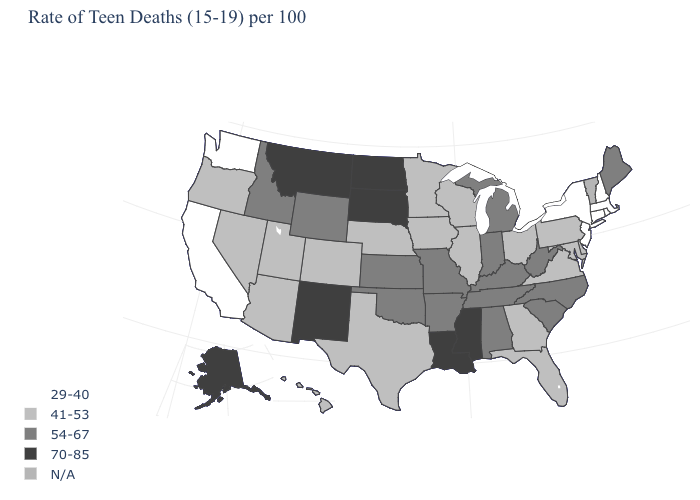Name the states that have a value in the range 41-53?
Write a very short answer. Arizona, Colorado, Delaware, Florida, Georgia, Hawaii, Illinois, Iowa, Maryland, Minnesota, Nebraska, Nevada, Ohio, Oregon, Pennsylvania, Texas, Utah, Virginia, Wisconsin. What is the value of Nevada?
Concise answer only. 41-53. What is the highest value in the USA?
Concise answer only. 70-85. Name the states that have a value in the range 29-40?
Keep it brief. California, Connecticut, Massachusetts, New Hampshire, New Jersey, New York, Rhode Island, Washington. Name the states that have a value in the range 54-67?
Write a very short answer. Alabama, Arkansas, Idaho, Indiana, Kansas, Kentucky, Maine, Michigan, Missouri, North Carolina, Oklahoma, South Carolina, Tennessee, West Virginia, Wyoming. Name the states that have a value in the range 54-67?
Give a very brief answer. Alabama, Arkansas, Idaho, Indiana, Kansas, Kentucky, Maine, Michigan, Missouri, North Carolina, Oklahoma, South Carolina, Tennessee, West Virginia, Wyoming. Name the states that have a value in the range 70-85?
Quick response, please. Alaska, Louisiana, Mississippi, Montana, New Mexico, North Dakota, South Dakota. Name the states that have a value in the range 70-85?
Be succinct. Alaska, Louisiana, Mississippi, Montana, New Mexico, North Dakota, South Dakota. Name the states that have a value in the range 54-67?
Write a very short answer. Alabama, Arkansas, Idaho, Indiana, Kansas, Kentucky, Maine, Michigan, Missouri, North Carolina, Oklahoma, South Carolina, Tennessee, West Virginia, Wyoming. Does Nevada have the lowest value in the USA?
Be succinct. No. Name the states that have a value in the range 70-85?
Give a very brief answer. Alaska, Louisiana, Mississippi, Montana, New Mexico, North Dakota, South Dakota. What is the lowest value in states that border Iowa?
Concise answer only. 41-53. Name the states that have a value in the range 29-40?
Keep it brief. California, Connecticut, Massachusetts, New Hampshire, New Jersey, New York, Rhode Island, Washington. Among the states that border Wisconsin , does Minnesota have the highest value?
Give a very brief answer. No. 